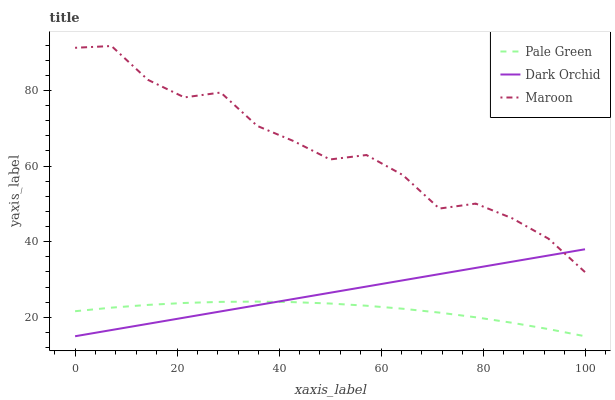Does Pale Green have the minimum area under the curve?
Answer yes or no. Yes. Does Maroon have the maximum area under the curve?
Answer yes or no. Yes. Does Dark Orchid have the minimum area under the curve?
Answer yes or no. No. Does Dark Orchid have the maximum area under the curve?
Answer yes or no. No. Is Dark Orchid the smoothest?
Answer yes or no. Yes. Is Maroon the roughest?
Answer yes or no. Yes. Is Maroon the smoothest?
Answer yes or no. No. Is Dark Orchid the roughest?
Answer yes or no. No. Does Pale Green have the lowest value?
Answer yes or no. Yes. Does Maroon have the lowest value?
Answer yes or no. No. Does Maroon have the highest value?
Answer yes or no. Yes. Does Dark Orchid have the highest value?
Answer yes or no. No. Is Pale Green less than Maroon?
Answer yes or no. Yes. Is Maroon greater than Pale Green?
Answer yes or no. Yes. Does Dark Orchid intersect Pale Green?
Answer yes or no. Yes. Is Dark Orchid less than Pale Green?
Answer yes or no. No. Is Dark Orchid greater than Pale Green?
Answer yes or no. No. Does Pale Green intersect Maroon?
Answer yes or no. No. 